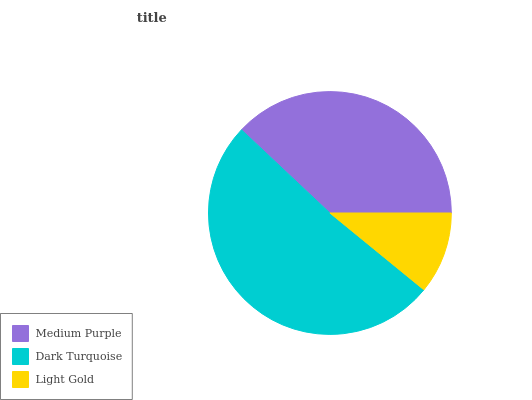Is Light Gold the minimum?
Answer yes or no. Yes. Is Dark Turquoise the maximum?
Answer yes or no. Yes. Is Dark Turquoise the minimum?
Answer yes or no. No. Is Light Gold the maximum?
Answer yes or no. No. Is Dark Turquoise greater than Light Gold?
Answer yes or no. Yes. Is Light Gold less than Dark Turquoise?
Answer yes or no. Yes. Is Light Gold greater than Dark Turquoise?
Answer yes or no. No. Is Dark Turquoise less than Light Gold?
Answer yes or no. No. Is Medium Purple the high median?
Answer yes or no. Yes. Is Medium Purple the low median?
Answer yes or no. Yes. Is Dark Turquoise the high median?
Answer yes or no. No. Is Dark Turquoise the low median?
Answer yes or no. No. 